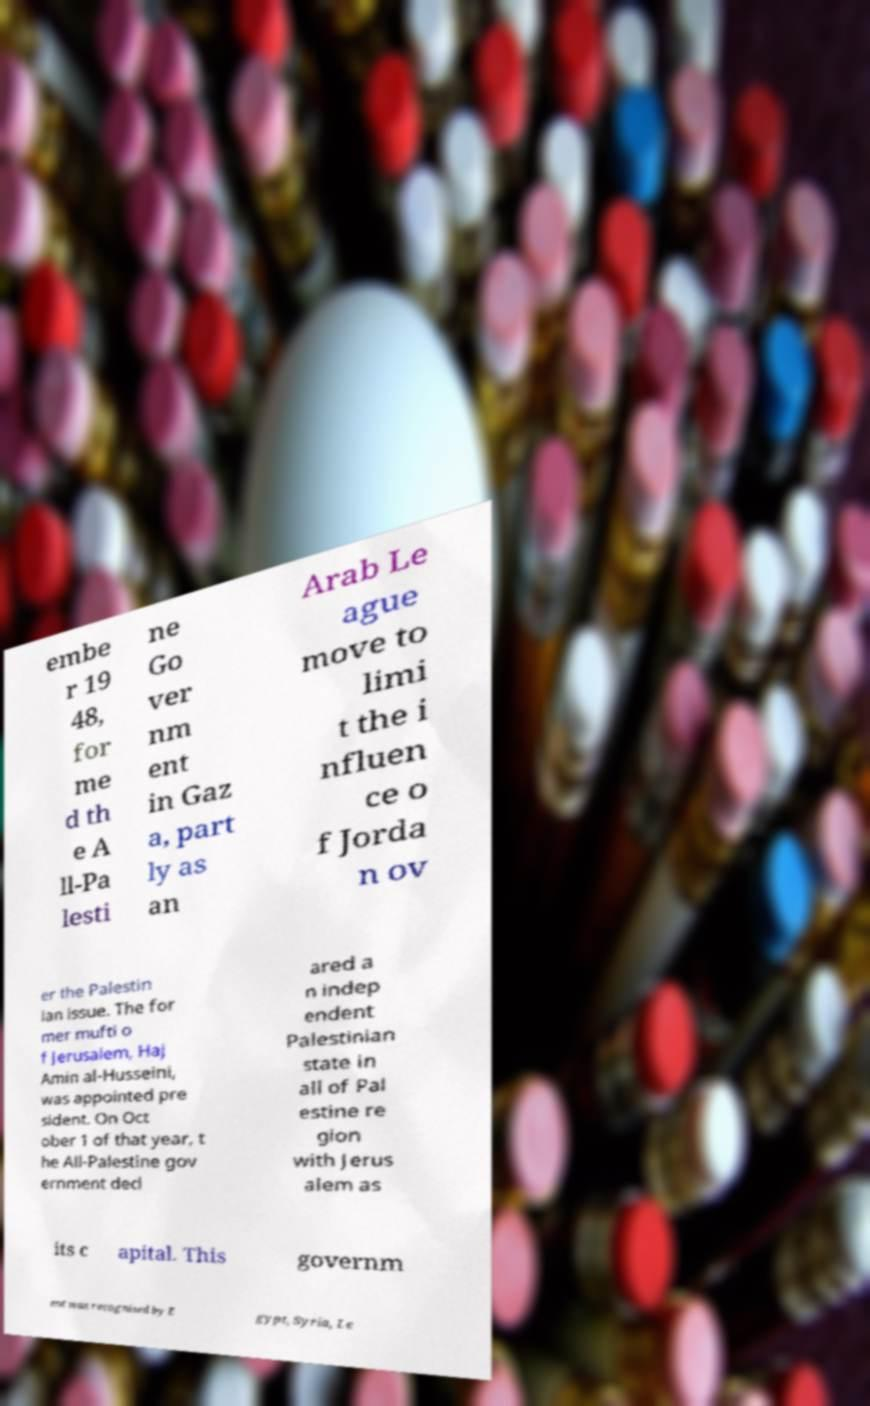Please read and relay the text visible in this image. What does it say? embe r 19 48, for me d th e A ll-Pa lesti ne Go ver nm ent in Gaz a, part ly as an Arab Le ague move to limi t the i nfluen ce o f Jorda n ov er the Palestin ian issue. The for mer mufti o f Jerusalem, Haj Amin al-Husseini, was appointed pre sident. On Oct ober 1 of that year, t he All-Palestine gov ernment decl ared a n indep endent Palestinian state in all of Pal estine re gion with Jerus alem as its c apital. This governm ent was recognised by E gypt, Syria, Le 